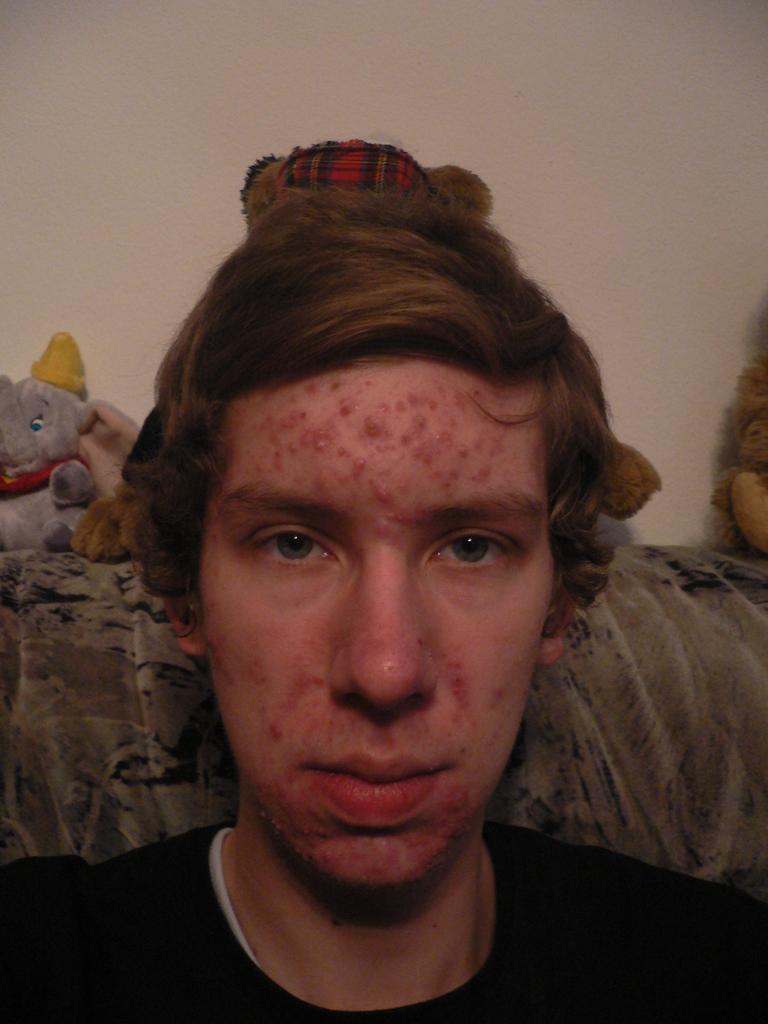Please provide a concise description of this image. In this image we can see a person sitting on the couch, there are few toys behind the person and the wall in the background. 